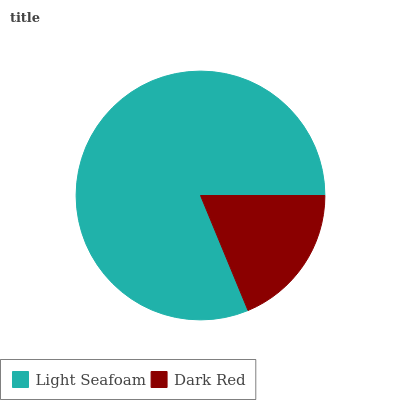Is Dark Red the minimum?
Answer yes or no. Yes. Is Light Seafoam the maximum?
Answer yes or no. Yes. Is Dark Red the maximum?
Answer yes or no. No. Is Light Seafoam greater than Dark Red?
Answer yes or no. Yes. Is Dark Red less than Light Seafoam?
Answer yes or no. Yes. Is Dark Red greater than Light Seafoam?
Answer yes or no. No. Is Light Seafoam less than Dark Red?
Answer yes or no. No. Is Light Seafoam the high median?
Answer yes or no. Yes. Is Dark Red the low median?
Answer yes or no. Yes. Is Dark Red the high median?
Answer yes or no. No. Is Light Seafoam the low median?
Answer yes or no. No. 